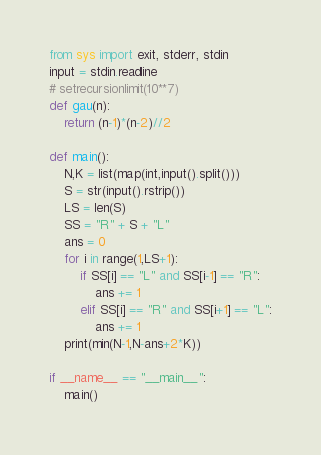Convert code to text. <code><loc_0><loc_0><loc_500><loc_500><_Python_>from sys import exit, stderr, stdin
input = stdin.readline
# setrecursionlimit(10**7)
def gau(n):
    return (n-1)*(n-2)//2

def main():
    N,K = list(map(int,input().split()))
    S = str(input().rstrip())
    LS = len(S)
    SS = "R" + S + "L"
    ans = 0
    for i in range(1,LS+1):
        if SS[i] == "L" and SS[i-1] == "R":
            ans += 1
        elif SS[i] == "R" and SS[i+1] == "L":
            ans += 1
    print(min(N-1,N-ans+2*K))

if __name__ == "__main__":
    main()
</code> 